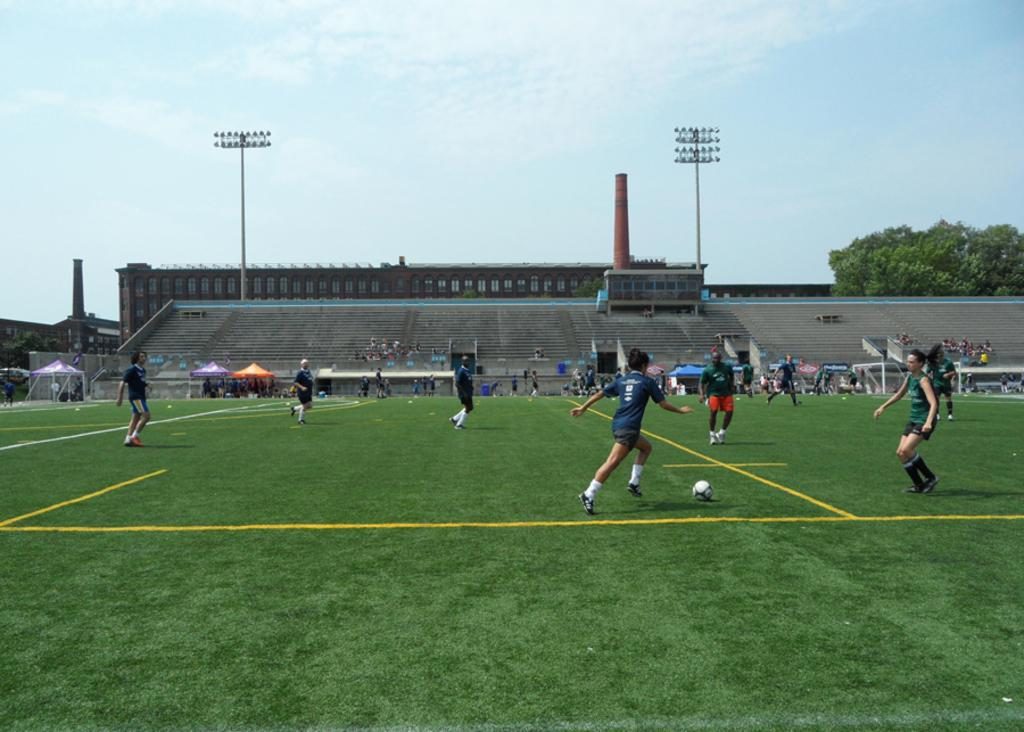What type of venue is shown in the image? There is a stadium in the image. What sport are the players engaged in? The players are playing football in the stadium. How many lights can be seen in the background of the image? There are five lights in the background of the image. What other elements can be seen in the background of the image? There are trees and the sky visible in the background of the image. What is the rate of the quiet plane flying over the stadium in the image? There is no plane present in the image, so it is not possible to determine its rate or noise level. 